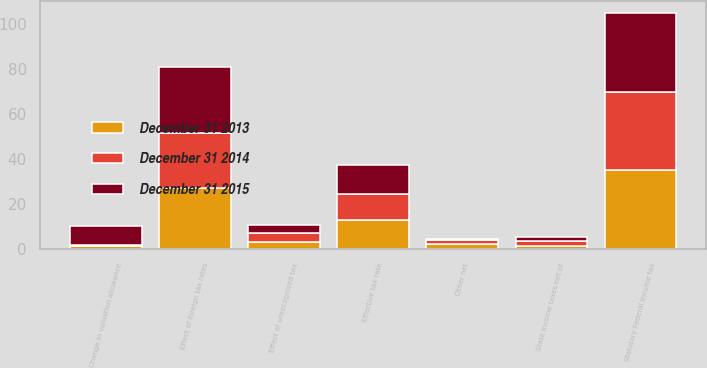Convert chart to OTSL. <chart><loc_0><loc_0><loc_500><loc_500><stacked_bar_chart><ecel><fcel>Statutory Federal income tax<fcel>State income taxes net of<fcel>Effect of foreign tax rates<fcel>Effect of unrecognized tax<fcel>Change in valuation allowance<fcel>Other net<fcel>Effective tax rate<nl><fcel>December 31 2015<fcel>35<fcel>1.6<fcel>29.2<fcel>3.5<fcel>8.2<fcel>0.5<fcel>12.6<nl><fcel>December 31 2014<fcel>35<fcel>2.5<fcel>24.3<fcel>3.9<fcel>0.4<fcel>2.1<fcel>11.8<nl><fcel>December 31 2013<fcel>35<fcel>1.3<fcel>27.4<fcel>3.3<fcel>1.5<fcel>2.1<fcel>12.8<nl></chart> 